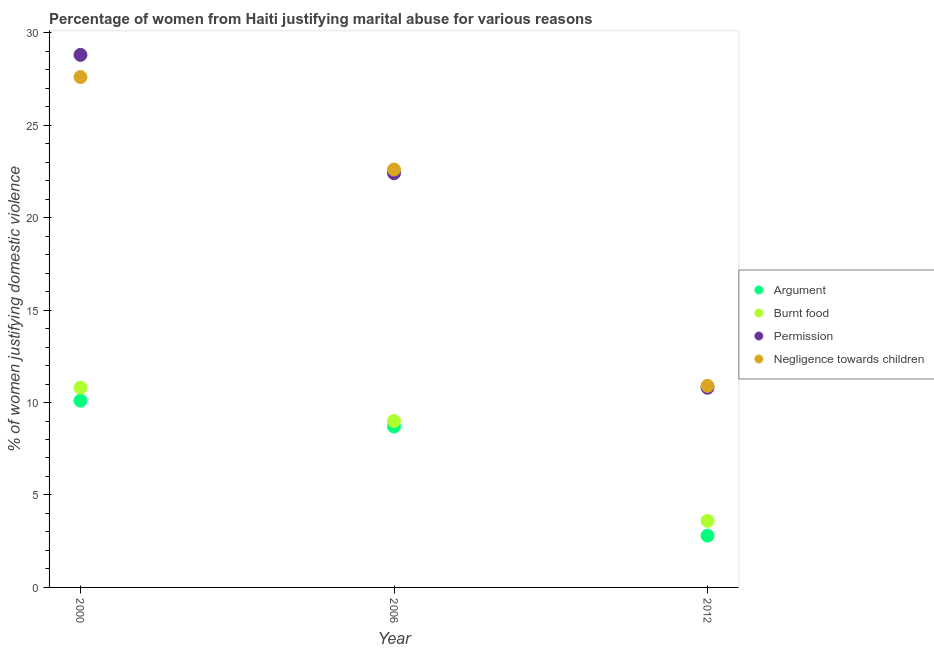How many different coloured dotlines are there?
Offer a terse response. 4. Across all years, what is the maximum percentage of women justifying abuse in the case of an argument?
Offer a terse response. 10.1. In which year was the percentage of women justifying abuse for showing negligence towards children minimum?
Offer a very short reply. 2012. What is the total percentage of women justifying abuse in the case of an argument in the graph?
Offer a very short reply. 21.6. What is the difference between the percentage of women justifying abuse in the case of an argument in 2000 and that in 2006?
Ensure brevity in your answer.  1.4. What is the difference between the percentage of women justifying abuse for going without permission in 2006 and the percentage of women justifying abuse in the case of an argument in 2012?
Provide a short and direct response. 19.6. What is the average percentage of women justifying abuse for showing negligence towards children per year?
Your response must be concise. 20.37. In the year 2006, what is the difference between the percentage of women justifying abuse in the case of an argument and percentage of women justifying abuse for burning food?
Your answer should be very brief. -0.3. What is the ratio of the percentage of women justifying abuse for going without permission in 2000 to that in 2012?
Your response must be concise. 2.67. Is the difference between the percentage of women justifying abuse for burning food in 2000 and 2006 greater than the difference between the percentage of women justifying abuse in the case of an argument in 2000 and 2006?
Your answer should be very brief. Yes. What is the difference between the highest and the second highest percentage of women justifying abuse in the case of an argument?
Your answer should be very brief. 1.4. Is the sum of the percentage of women justifying abuse in the case of an argument in 2006 and 2012 greater than the maximum percentage of women justifying abuse for burning food across all years?
Keep it short and to the point. Yes. Is it the case that in every year, the sum of the percentage of women justifying abuse for showing negligence towards children and percentage of women justifying abuse for burning food is greater than the sum of percentage of women justifying abuse in the case of an argument and percentage of women justifying abuse for going without permission?
Provide a succinct answer. No. Is the percentage of women justifying abuse for burning food strictly greater than the percentage of women justifying abuse for showing negligence towards children over the years?
Your answer should be very brief. No. What is the difference between two consecutive major ticks on the Y-axis?
Give a very brief answer. 5. Does the graph contain any zero values?
Your response must be concise. No. Does the graph contain grids?
Your response must be concise. No. What is the title of the graph?
Provide a succinct answer. Percentage of women from Haiti justifying marital abuse for various reasons. What is the label or title of the Y-axis?
Ensure brevity in your answer.  % of women justifying domestic violence. What is the % of women justifying domestic violence in Argument in 2000?
Your answer should be very brief. 10.1. What is the % of women justifying domestic violence of Permission in 2000?
Make the answer very short. 28.8. What is the % of women justifying domestic violence in Negligence towards children in 2000?
Give a very brief answer. 27.6. What is the % of women justifying domestic violence in Argument in 2006?
Ensure brevity in your answer.  8.7. What is the % of women justifying domestic violence of Burnt food in 2006?
Your response must be concise. 9. What is the % of women justifying domestic violence in Permission in 2006?
Give a very brief answer. 22.4. What is the % of women justifying domestic violence of Negligence towards children in 2006?
Your response must be concise. 22.6. What is the % of women justifying domestic violence in Argument in 2012?
Your answer should be very brief. 2.8. What is the % of women justifying domestic violence of Permission in 2012?
Offer a very short reply. 10.8. What is the % of women justifying domestic violence of Negligence towards children in 2012?
Give a very brief answer. 10.9. Across all years, what is the maximum % of women justifying domestic violence of Argument?
Ensure brevity in your answer.  10.1. Across all years, what is the maximum % of women justifying domestic violence in Burnt food?
Provide a short and direct response. 10.8. Across all years, what is the maximum % of women justifying domestic violence in Permission?
Keep it short and to the point. 28.8. Across all years, what is the maximum % of women justifying domestic violence in Negligence towards children?
Your answer should be compact. 27.6. Across all years, what is the minimum % of women justifying domestic violence in Argument?
Your response must be concise. 2.8. What is the total % of women justifying domestic violence of Argument in the graph?
Give a very brief answer. 21.6. What is the total % of women justifying domestic violence in Burnt food in the graph?
Provide a succinct answer. 23.4. What is the total % of women justifying domestic violence in Permission in the graph?
Make the answer very short. 62. What is the total % of women justifying domestic violence in Negligence towards children in the graph?
Ensure brevity in your answer.  61.1. What is the difference between the % of women justifying domestic violence of Argument in 2000 and that in 2006?
Give a very brief answer. 1.4. What is the difference between the % of women justifying domestic violence of Burnt food in 2000 and that in 2006?
Your answer should be very brief. 1.8. What is the difference between the % of women justifying domestic violence of Permission in 2000 and that in 2012?
Your answer should be very brief. 18. What is the difference between the % of women justifying domestic violence of Argument in 2006 and that in 2012?
Offer a very short reply. 5.9. What is the difference between the % of women justifying domestic violence in Burnt food in 2006 and that in 2012?
Keep it short and to the point. 5.4. What is the difference between the % of women justifying domestic violence of Permission in 2006 and that in 2012?
Your response must be concise. 11.6. What is the difference between the % of women justifying domestic violence in Argument in 2000 and the % of women justifying domestic violence in Permission in 2006?
Offer a very short reply. -12.3. What is the difference between the % of women justifying domestic violence of Argument in 2000 and the % of women justifying domestic violence of Negligence towards children in 2006?
Your answer should be very brief. -12.5. What is the difference between the % of women justifying domestic violence of Argument in 2000 and the % of women justifying domestic violence of Negligence towards children in 2012?
Give a very brief answer. -0.8. What is the difference between the % of women justifying domestic violence of Argument in 2006 and the % of women justifying domestic violence of Burnt food in 2012?
Ensure brevity in your answer.  5.1. What is the difference between the % of women justifying domestic violence of Burnt food in 2006 and the % of women justifying domestic violence of Negligence towards children in 2012?
Keep it short and to the point. -1.9. What is the average % of women justifying domestic violence in Burnt food per year?
Offer a very short reply. 7.8. What is the average % of women justifying domestic violence in Permission per year?
Provide a short and direct response. 20.67. What is the average % of women justifying domestic violence of Negligence towards children per year?
Your response must be concise. 20.37. In the year 2000, what is the difference between the % of women justifying domestic violence in Argument and % of women justifying domestic violence in Burnt food?
Offer a terse response. -0.7. In the year 2000, what is the difference between the % of women justifying domestic violence in Argument and % of women justifying domestic violence in Permission?
Your answer should be compact. -18.7. In the year 2000, what is the difference between the % of women justifying domestic violence in Argument and % of women justifying domestic violence in Negligence towards children?
Ensure brevity in your answer.  -17.5. In the year 2000, what is the difference between the % of women justifying domestic violence of Burnt food and % of women justifying domestic violence of Permission?
Give a very brief answer. -18. In the year 2000, what is the difference between the % of women justifying domestic violence in Burnt food and % of women justifying domestic violence in Negligence towards children?
Offer a terse response. -16.8. In the year 2006, what is the difference between the % of women justifying domestic violence in Argument and % of women justifying domestic violence in Permission?
Keep it short and to the point. -13.7. In the year 2006, what is the difference between the % of women justifying domestic violence in Burnt food and % of women justifying domestic violence in Permission?
Offer a very short reply. -13.4. In the year 2006, what is the difference between the % of women justifying domestic violence of Permission and % of women justifying domestic violence of Negligence towards children?
Make the answer very short. -0.2. In the year 2012, what is the difference between the % of women justifying domestic violence in Argument and % of women justifying domestic violence in Burnt food?
Your answer should be very brief. -0.8. In the year 2012, what is the difference between the % of women justifying domestic violence of Argument and % of women justifying domestic violence of Permission?
Keep it short and to the point. -8. In the year 2012, what is the difference between the % of women justifying domestic violence in Argument and % of women justifying domestic violence in Negligence towards children?
Your answer should be very brief. -8.1. In the year 2012, what is the difference between the % of women justifying domestic violence of Burnt food and % of women justifying domestic violence of Negligence towards children?
Provide a succinct answer. -7.3. What is the ratio of the % of women justifying domestic violence of Argument in 2000 to that in 2006?
Offer a terse response. 1.16. What is the ratio of the % of women justifying domestic violence of Negligence towards children in 2000 to that in 2006?
Your answer should be very brief. 1.22. What is the ratio of the % of women justifying domestic violence in Argument in 2000 to that in 2012?
Give a very brief answer. 3.61. What is the ratio of the % of women justifying domestic violence of Burnt food in 2000 to that in 2012?
Offer a very short reply. 3. What is the ratio of the % of women justifying domestic violence in Permission in 2000 to that in 2012?
Your answer should be very brief. 2.67. What is the ratio of the % of women justifying domestic violence in Negligence towards children in 2000 to that in 2012?
Keep it short and to the point. 2.53. What is the ratio of the % of women justifying domestic violence in Argument in 2006 to that in 2012?
Offer a terse response. 3.11. What is the ratio of the % of women justifying domestic violence in Permission in 2006 to that in 2012?
Make the answer very short. 2.07. What is the ratio of the % of women justifying domestic violence of Negligence towards children in 2006 to that in 2012?
Your answer should be compact. 2.07. What is the difference between the highest and the second highest % of women justifying domestic violence of Burnt food?
Offer a terse response. 1.8. What is the difference between the highest and the second highest % of women justifying domestic violence in Negligence towards children?
Ensure brevity in your answer.  5. What is the difference between the highest and the lowest % of women justifying domestic violence in Argument?
Make the answer very short. 7.3. What is the difference between the highest and the lowest % of women justifying domestic violence of Permission?
Make the answer very short. 18. 